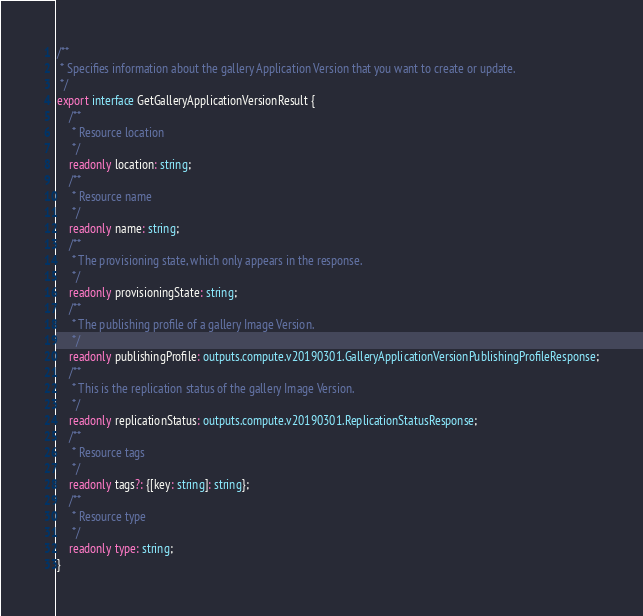<code> <loc_0><loc_0><loc_500><loc_500><_TypeScript_>
/**
 * Specifies information about the gallery Application Version that you want to create or update.
 */
export interface GetGalleryApplicationVersionResult {
    /**
     * Resource location
     */
    readonly location: string;
    /**
     * Resource name
     */
    readonly name: string;
    /**
     * The provisioning state, which only appears in the response.
     */
    readonly provisioningState: string;
    /**
     * The publishing profile of a gallery Image Version.
     */
    readonly publishingProfile: outputs.compute.v20190301.GalleryApplicationVersionPublishingProfileResponse;
    /**
     * This is the replication status of the gallery Image Version.
     */
    readonly replicationStatus: outputs.compute.v20190301.ReplicationStatusResponse;
    /**
     * Resource tags
     */
    readonly tags?: {[key: string]: string};
    /**
     * Resource type
     */
    readonly type: string;
}
</code> 